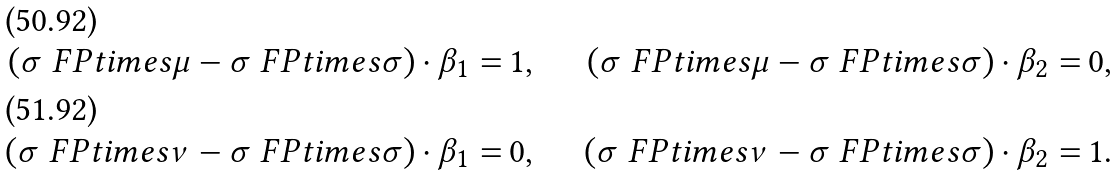<formula> <loc_0><loc_0><loc_500><loc_500>\left ( \sigma \ F P t i m e s \mu - \sigma \ F P t i m e s \sigma \right ) \cdot \beta _ { 1 } = & \, 1 , & \quad \left ( \sigma \ F P t i m e s \mu - \sigma \ F P t i m e s \sigma \right ) \cdot \beta _ { 2 } = & \, 0 , \\ \left ( \sigma \ F P t i m e s \nu - \sigma \ F P t i m e s \sigma \right ) \cdot \beta _ { 1 } = & \, 0 , & \quad \left ( \sigma \ F P t i m e s \nu - \sigma \ F P t i m e s \sigma \right ) \cdot \beta _ { 2 } = & \, 1 .</formula> 